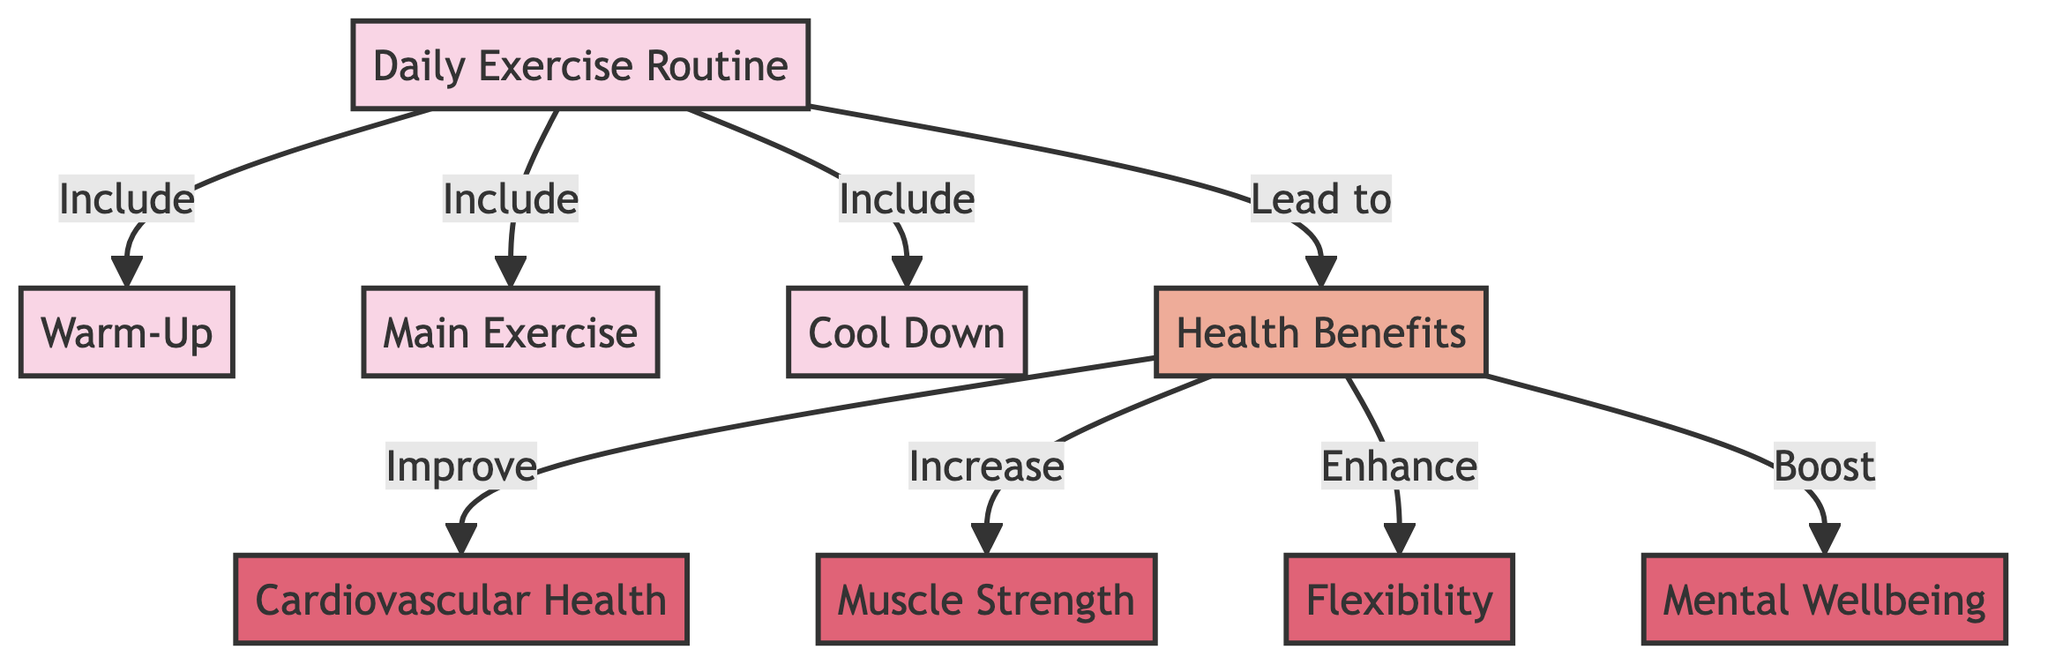What are the three components of the daily exercise routine? The diagram shows the daily exercise routine consists of three main components: Warm-Up, Main Exercise, and Cool Down. These components are directly connected to the daily exercise routine node.
Answer: Warm-Up, Main Exercise, Cool Down How many health benefits are listed in the diagram? By examining the health benefits node, we see that there are four distinct health benefits: Cardiovascular Health, Muscle Strength, Flexibility, and Mental Wellbeing.
Answer: Four What do warm-up activities lead to in the context of the diagram? The flowchart indicates that the Warm-Up leads to the overall Daily Exercise Routine, which contributes to various Health Benefits later on in the diagram.
Answer: Daily Exercise Routine Which health benefit is associated with muscle strength? In the diagram, Muscle Strength is indicated to be one of the health benefits that stem from the overall Health Benefits node, specifically represented as an increase.
Answer: Increase What is the relationship between the main exercise and health benefits? The diagram shows a direct relationship indicating that the Main Exercise contributes to health benefits, which include several specific areas like flexibility and cardiovascular health.
Answer: Lead to Which component leads to flexibility improvement? The diagram illustrates that flexibility is enhanced as a result of the overall health benefits, which come from participating in the daily exercise routine that includes the main exercise.
Answer: Main Exercise How is mental wellbeing described in terms of its connection to exercise? The flowchart indicates that mental wellbeing is boosted as part of the health benefits derived from the daily exercise routine, showing a positive relationship between the two.
Answer: Boost What element connects all parts of the daily exercise routine? The daily exercise routine encapsulates all three components (Warm-Up, Main Exercise, Cool Down) and directly leads to the overall Health Benefits node.
Answer: Daily Exercise Routine How are health benefits categorized in the diagram? Health benefits are visually categorized into types in the diagram, denoted by different colors and classes: cardiovascular health, muscle strength, flexibility, and mental wellbeing are all classified under health benefits.
Answer: Health Benefits 